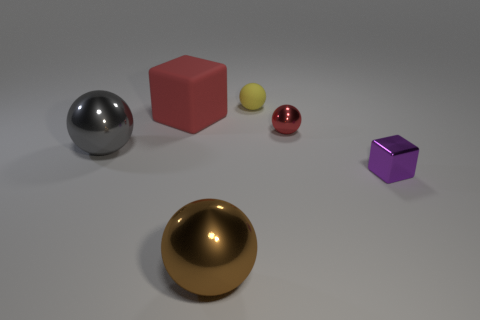The red rubber thing that is the same size as the gray metallic sphere is what shape?
Provide a short and direct response. Cube. Do the brown thing and the large red thing have the same shape?
Offer a terse response. No. How many small purple things are the same shape as the gray thing?
Provide a short and direct response. 0. What number of yellow balls are to the right of the purple thing?
Your response must be concise. 0. Do the tiny sphere that is in front of the matte cube and the large cube have the same color?
Provide a short and direct response. Yes. How many yellow objects are the same size as the gray shiny sphere?
Your response must be concise. 0. The large red thing that is the same material as the yellow thing is what shape?
Keep it short and to the point. Cube. Is there a metal ball of the same color as the rubber cube?
Keep it short and to the point. Yes. What material is the red sphere?
Offer a terse response. Metal. What number of objects are either yellow rubber things or small red cylinders?
Offer a terse response. 1. 